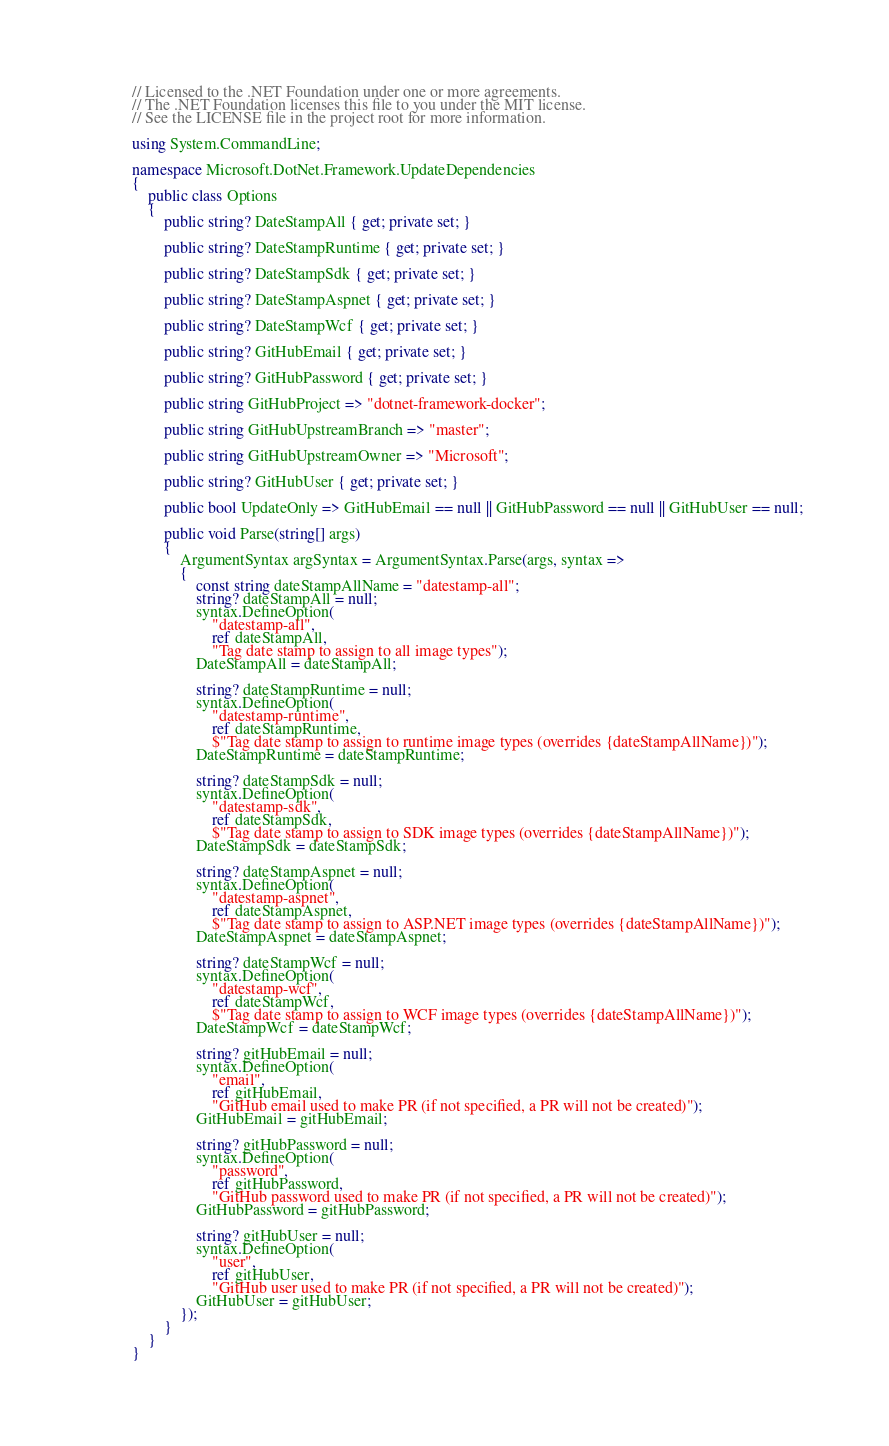Convert code to text. <code><loc_0><loc_0><loc_500><loc_500><_C#_>// Licensed to the .NET Foundation under one or more agreements.
// The .NET Foundation licenses this file to you under the MIT license.
// See the LICENSE file in the project root for more information.

using System.CommandLine;

namespace Microsoft.DotNet.Framework.UpdateDependencies
{
    public class Options
    {
        public string? DateStampAll { get; private set; }

        public string? DateStampRuntime { get; private set; }

        public string? DateStampSdk { get; private set; }

        public string? DateStampAspnet { get; private set; }

        public string? DateStampWcf { get; private set; }

        public string? GitHubEmail { get; private set; }

        public string? GitHubPassword { get; private set; }

        public string GitHubProject => "dotnet-framework-docker";

        public string GitHubUpstreamBranch => "master";

        public string GitHubUpstreamOwner => "Microsoft";

        public string? GitHubUser { get; private set; }

        public bool UpdateOnly => GitHubEmail == null || GitHubPassword == null || GitHubUser == null;

        public void Parse(string[] args)
        {
            ArgumentSyntax argSyntax = ArgumentSyntax.Parse(args, syntax =>
            {
                const string dateStampAllName = "datestamp-all";
                string? dateStampAll = null;
                syntax.DefineOption(
                    "datestamp-all",
                    ref dateStampAll,
                    "Tag date stamp to assign to all image types");
                DateStampAll = dateStampAll;

                string? dateStampRuntime = null;
                syntax.DefineOption(
                    "datestamp-runtime",
                    ref dateStampRuntime,
                    $"Tag date stamp to assign to runtime image types (overrides {dateStampAllName})");
                DateStampRuntime = dateStampRuntime;

                string? dateStampSdk = null;
                syntax.DefineOption(
                    "datestamp-sdk",
                    ref dateStampSdk,
                    $"Tag date stamp to assign to SDK image types (overrides {dateStampAllName})");
                DateStampSdk = dateStampSdk;

                string? dateStampAspnet = null;
                syntax.DefineOption(
                    "datestamp-aspnet",
                    ref dateStampAspnet,
                    $"Tag date stamp to assign to ASP.NET image types (overrides {dateStampAllName})");
                DateStampAspnet = dateStampAspnet;

                string? dateStampWcf = null;
                syntax.DefineOption(
                    "datestamp-wcf",
                    ref dateStampWcf,
                    $"Tag date stamp to assign to WCF image types (overrides {dateStampAllName})");
                DateStampWcf = dateStampWcf;

                string? gitHubEmail = null;
                syntax.DefineOption(
                    "email",
                    ref gitHubEmail,
                    "GitHub email used to make PR (if not specified, a PR will not be created)");
                GitHubEmail = gitHubEmail;

                string? gitHubPassword = null;
                syntax.DefineOption(
                    "password",
                    ref gitHubPassword,
                    "GitHub password used to make PR (if not specified, a PR will not be created)");
                GitHubPassword = gitHubPassword;

                string? gitHubUser = null;
                syntax.DefineOption(
                    "user",
                    ref gitHubUser,
                    "GitHub user used to make PR (if not specified, a PR will not be created)");
                GitHubUser = gitHubUser;
            });
        }
    }
}
</code> 